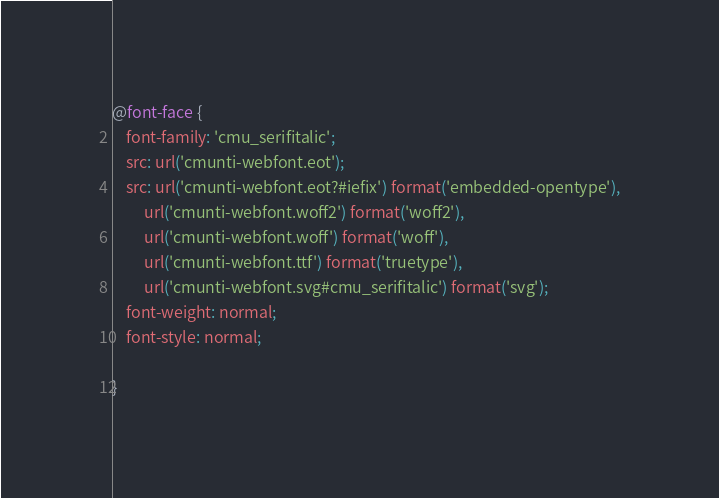<code> <loc_0><loc_0><loc_500><loc_500><_CSS_>@font-face {
    font-family: 'cmu_serifitalic';
    src: url('cmunti-webfont.eot');
    src: url('cmunti-webfont.eot?#iefix') format('embedded-opentype'),
         url('cmunti-webfont.woff2') format('woff2'),
         url('cmunti-webfont.woff') format('woff'),
         url('cmunti-webfont.ttf') format('truetype'),
         url('cmunti-webfont.svg#cmu_serifitalic') format('svg');
    font-weight: normal;
    font-style: normal;

}

</code> 